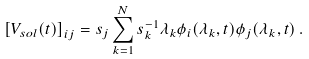Convert formula to latex. <formula><loc_0><loc_0><loc_500><loc_500>\left [ V _ { s o l } ( t ) \right ] _ { i j } = s _ { j } \sum _ { k = 1 } ^ { N } s _ { k } ^ { - 1 } \lambda _ { k } \phi _ { i } ( \lambda _ { k } , t ) \phi _ { j } ( \lambda _ { k } , t ) \, .</formula> 